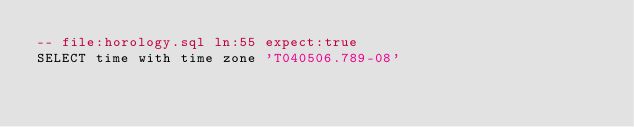Convert code to text. <code><loc_0><loc_0><loc_500><loc_500><_SQL_>-- file:horology.sql ln:55 expect:true
SELECT time with time zone 'T040506.789-08'
</code> 